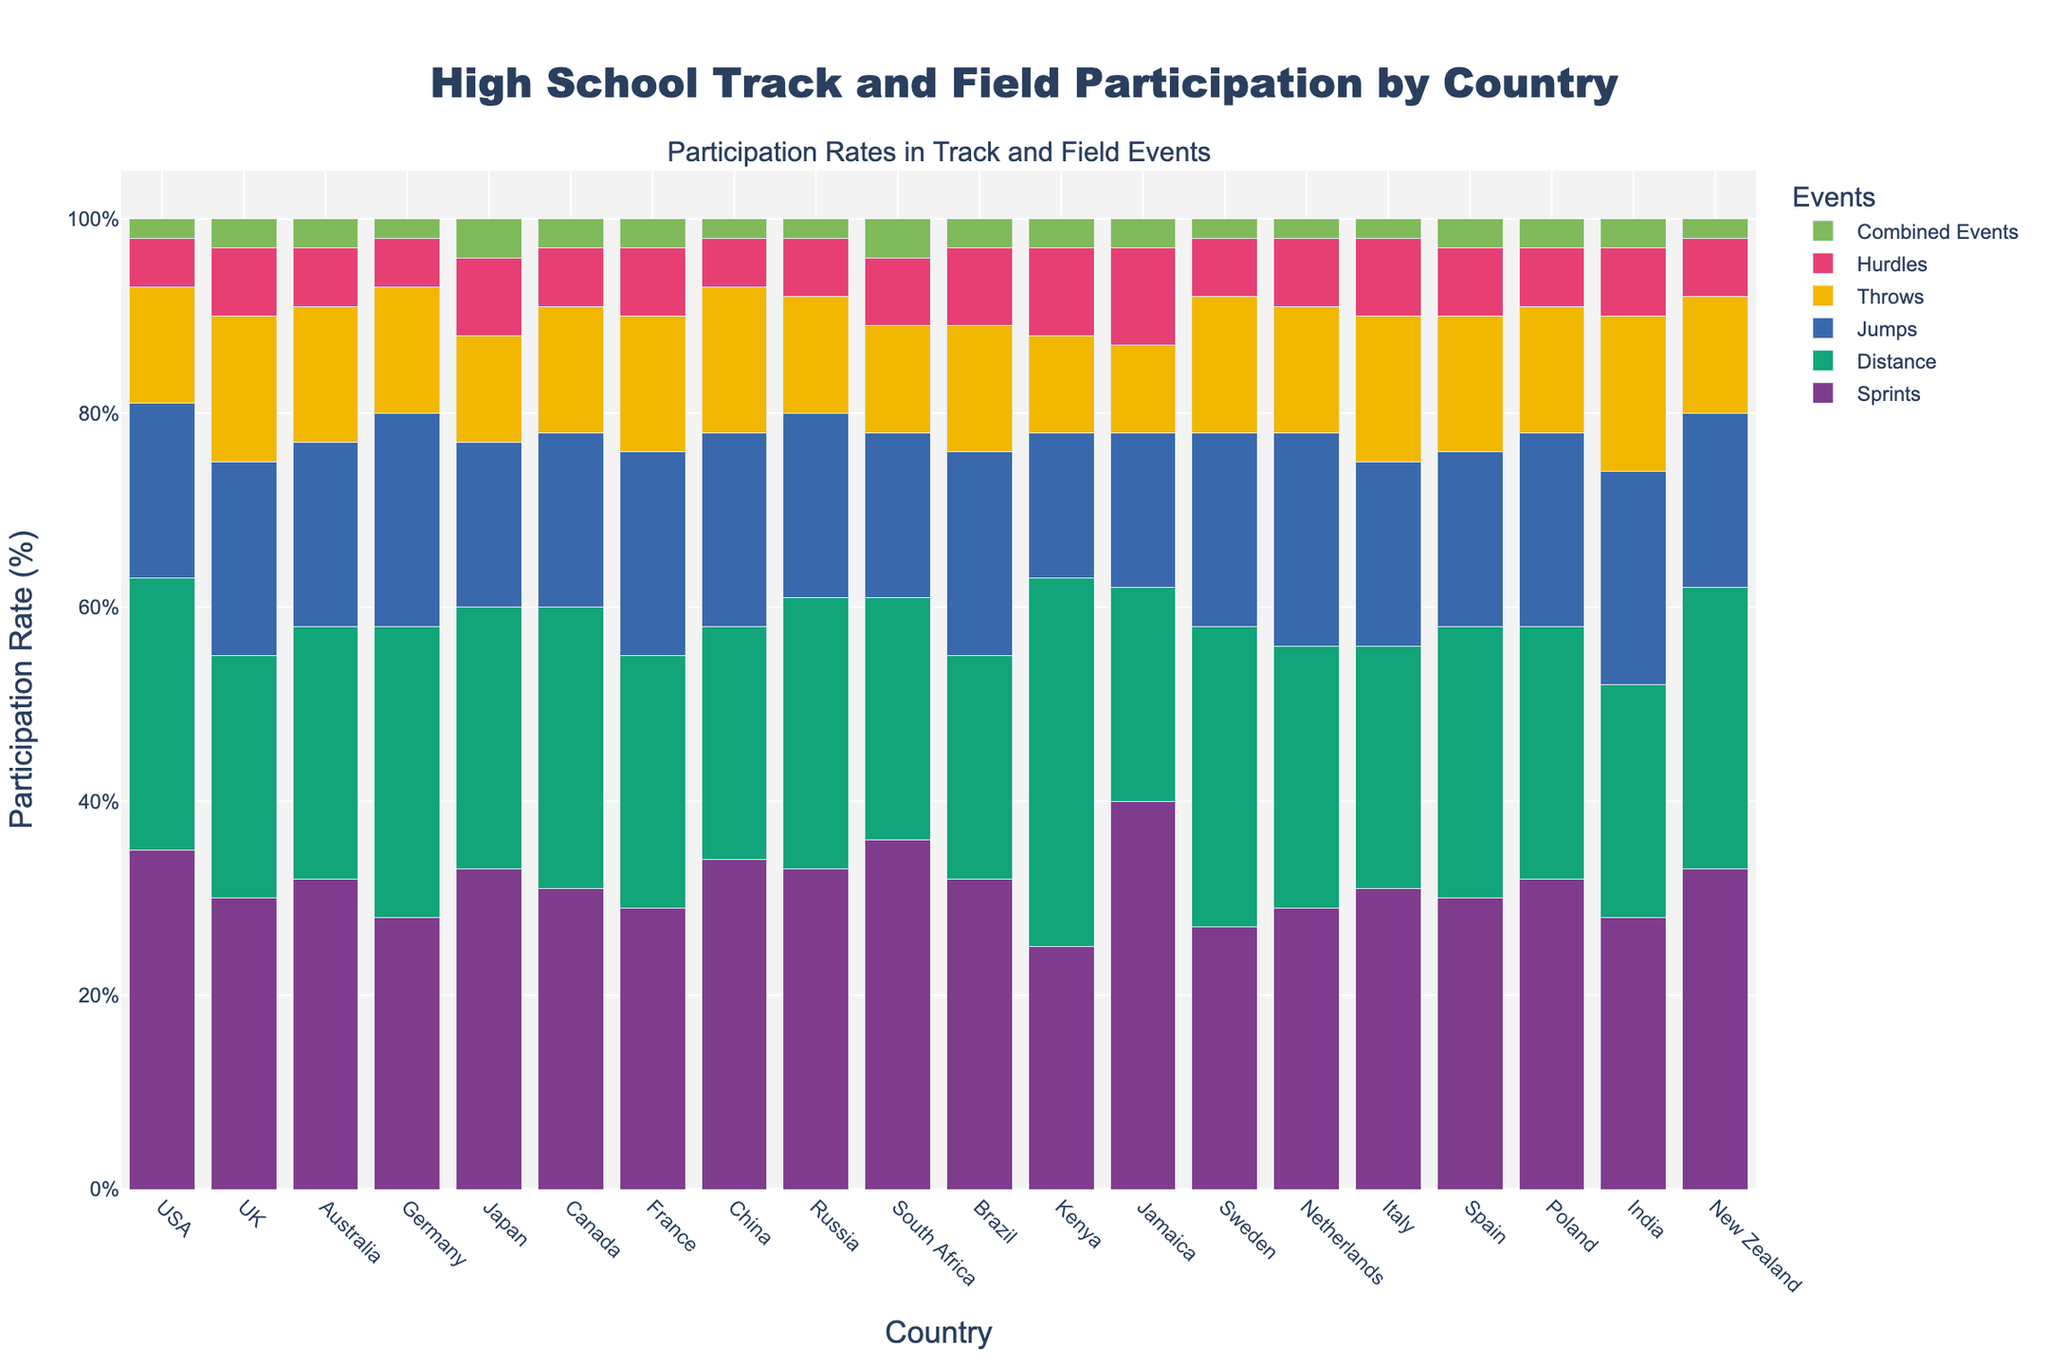Which country has the highest participation rate in sprints? By examining the heights of the bars representing sprints for each country, the tallest bar indicates the country with the highest participation rate in sprints. Jamaica has the tallest bar for sprints.
Answer: Jamaica Which two countries have the lowest participation rates in combined events? By checking the bars representing combined events for each country, the two shortest bars belong to the countries with the lowest participation rates. The USA and Germany have the shortest bars for combined events.
Answer: USA, Germany What is the average participation rate of hurdles across all countries? Sum the participation rates of hurdles for all countries and divide by the number of countries. \( (5 + 7 + 6 + 5 + 8 + 6 + 7 + 5 + 6 + 7 + 8 + 9 + 10 + 6 + 7 + 8 + 7 + 6 + 7 + 6) \div 20 = 6.55 \)
Answer: 6.55 Which country has the highest combined participation rate for distance and jumps events? Sum the participation rates for distance and jumps for each country and compare the totals. Ethiopia has the highest total for combined participation in distance and jumps, which is 38 for distance and 15 for jumps, totaling 53.
Answer: Kenya Compare the participation rates in throws and jumps for Germany. Which one is higher? By looking at the heights of the bars for Germany’s throws and jumps, the bar for jumps is higher than the one for throws.
Answer: Jumps Which country shows the highest participation in distance events and what is that rate? Locate the tallest bar for distance events across all countries. Kenya has the tallest bar for distance events with a rate of 38.
Answer: Kenya, 38 What is the difference in participation rates between Italy and Spain for throws? Subtract the participation rate of throws for Spain from that of Italy. \( 15 - 14 = 1 \)
Answer: 1 What is the median participation rate in jumps across all countries? Sort the jumps participation rates and find the middle value (or average of the two middle values since there's an even number of data points). Sorted rates: 15, 16, 17, 18, 18, 18, 19, 19, 19, 20, 20, 20, 21, 21, 22, 22, 22 Median of 20 and 20.
Answer: 20 For Australia, what is the combined participation rate in distance and combined events? Add the participation rates for distance and combined events for Australia. \( 26 + 3 = 29 \)
Answer: 29 Which country has a higher participation rate in hurdles, Brazil or Jamaica? Compare the bars representing hurdles for Brazil and Jamaica. The bar for Jamaica (10) is higher than the bar for Brazil (8).
Answer: Jamaica 